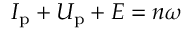Convert formula to latex. <formula><loc_0><loc_0><loc_500><loc_500>I _ { p } + U _ { p } + E = n \omega</formula> 